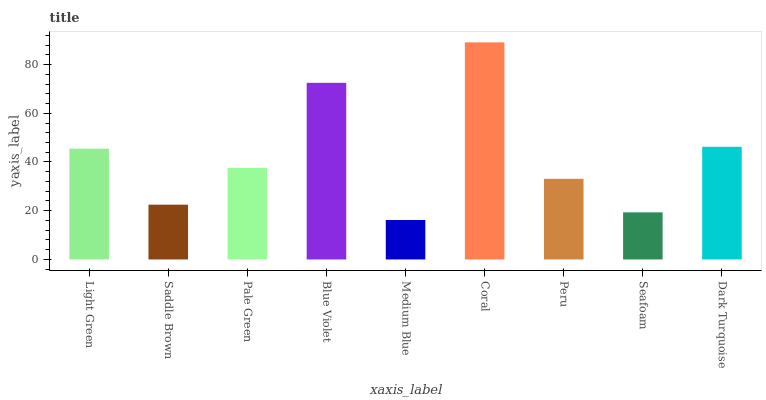Is Medium Blue the minimum?
Answer yes or no. Yes. Is Coral the maximum?
Answer yes or no. Yes. Is Saddle Brown the minimum?
Answer yes or no. No. Is Saddle Brown the maximum?
Answer yes or no. No. Is Light Green greater than Saddle Brown?
Answer yes or no. Yes. Is Saddle Brown less than Light Green?
Answer yes or no. Yes. Is Saddle Brown greater than Light Green?
Answer yes or no. No. Is Light Green less than Saddle Brown?
Answer yes or no. No. Is Pale Green the high median?
Answer yes or no. Yes. Is Pale Green the low median?
Answer yes or no. Yes. Is Seafoam the high median?
Answer yes or no. No. Is Light Green the low median?
Answer yes or no. No. 